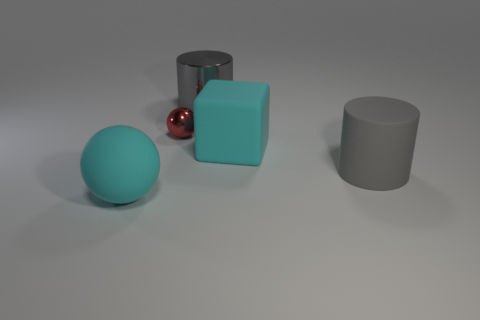The cyan rubber object in front of the gray rubber object has what shape? The cyan rubber object situated in front of the gray one is a cube, characterized by its equal width, height, and depth that give it a distinct six-faced square appearance. 